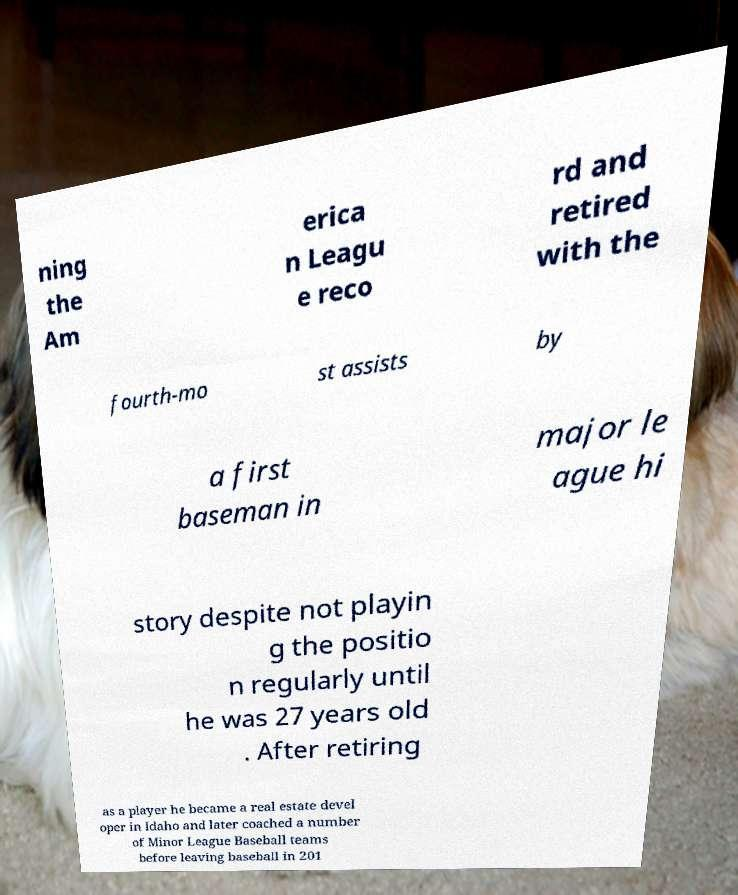Please read and relay the text visible in this image. What does it say? ning the Am erica n Leagu e reco rd and retired with the fourth-mo st assists by a first baseman in major le ague hi story despite not playin g the positio n regularly until he was 27 years old . After retiring as a player he became a real estate devel oper in Idaho and later coached a number of Minor League Baseball teams before leaving baseball in 201 